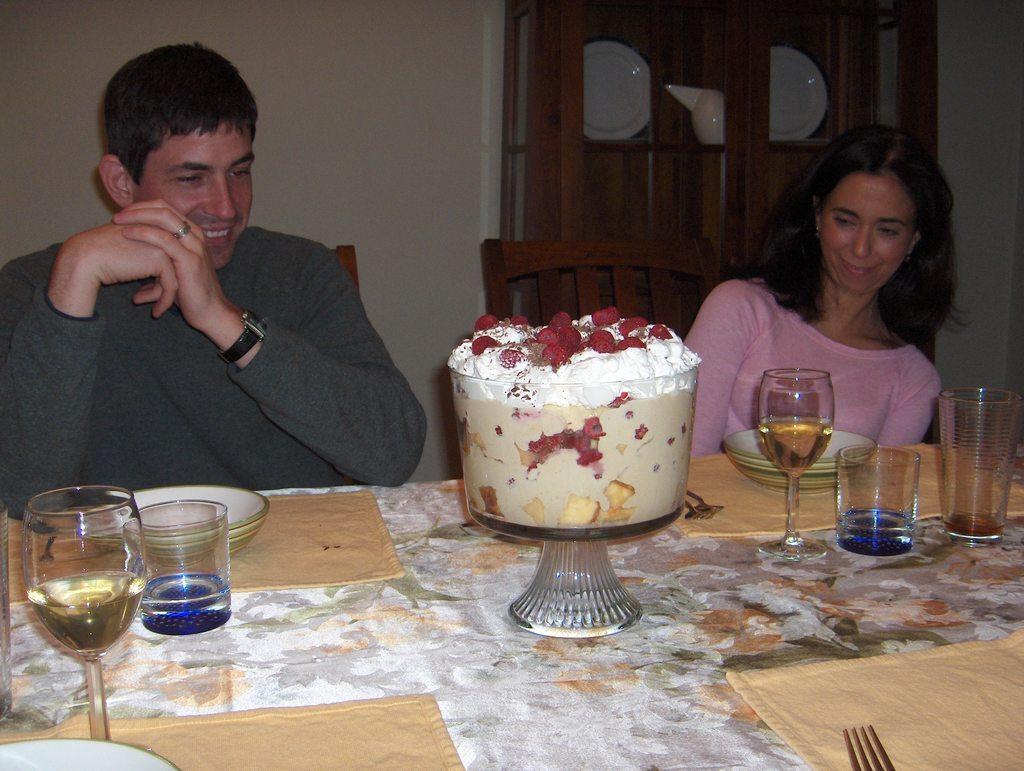How would you summarize this image in a sentence or two? In this image there is woman and a man sitting on chairs, in front of them there is a table, on that table there are bowls, glasses and cake and forks , in the background there is a wall to that wall there is a cupboard, in that cupboard there are plates. 